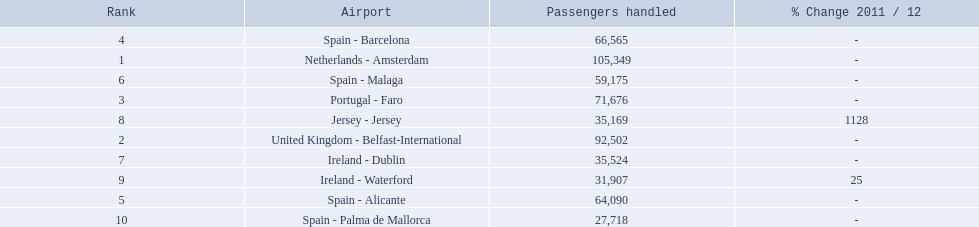What are all the passengers handled values for london southend airport? 105,349, 92,502, 71,676, 66,565, 64,090, 59,175, 35,524, 35,169, 31,907, 27,718. Which are 30,000 or less? 27,718. What airport is this for? Spain - Palma de Mallorca. 